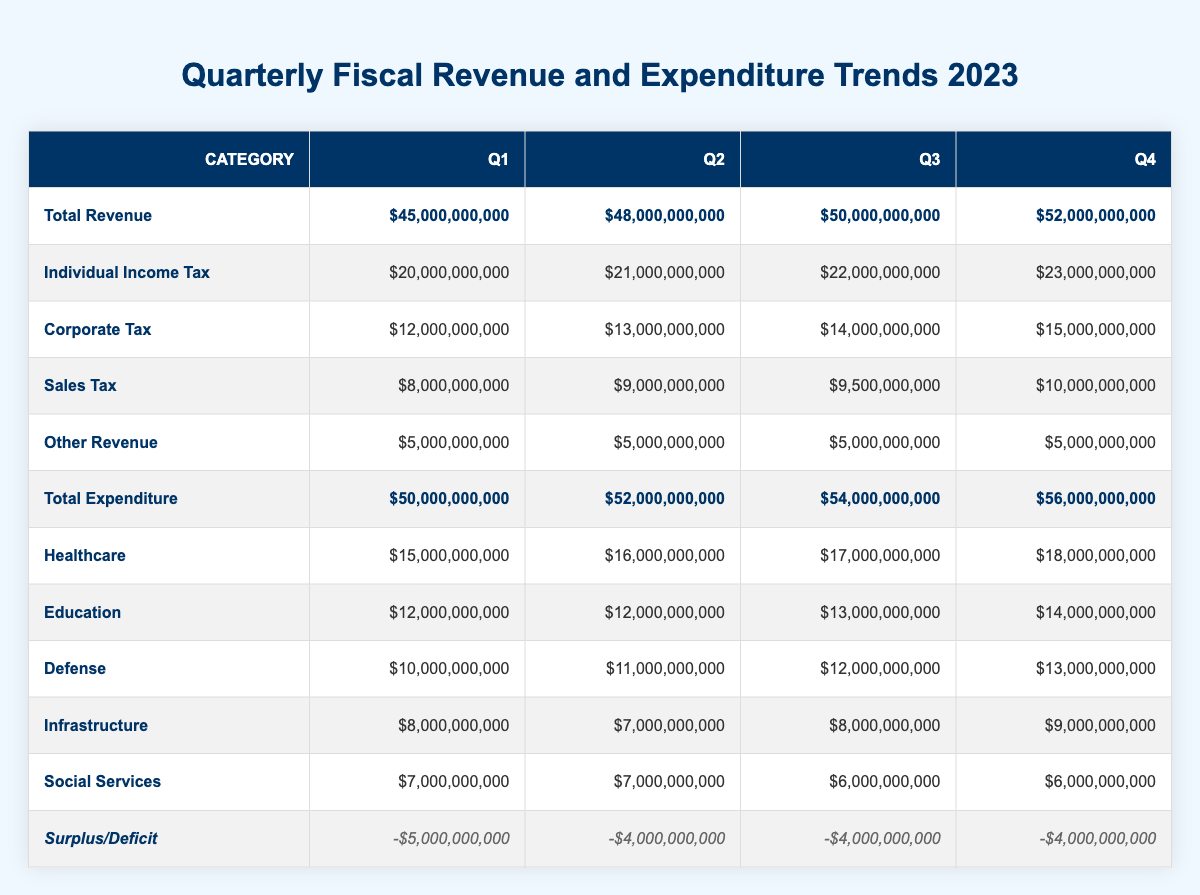What is the total revenue for Q3? The table lists the total revenue for each quarter. For Q3, it shows $50,000,000,000 as the total revenue.
Answer: $50,000,000,000 What was the total expenditure in Q2? The table provides the total expenditure for each quarter. For Q2, the total expenditure is $52,000,000,000.
Answer: $52,000,000,000 In which quarter was the highest individual income tax collected, and what was the amount? The table shows individual income tax for each quarter. The highest amount is $23,000,000,000 in Q4.
Answer: Q4, $23,000,000,000 What is the average total revenue across all quarters? The total revenues for each quarter are $45,000,000,000 (Q1), $48,000,000,000 (Q2), $50,000,000,000 (Q3), and $52,000,000,000 (Q4). The average is calculated as (45 + 48 + 50 + 52) / 4 = 48.75 billion.
Answer: $48,750,000,000 Is the total expenditure higher than total revenue in all quarters? By comparing total revenue and total expenditure for each quarter, in Q1 ($45B vs. $50B), Q2 ($48B vs. $52B), Q3 ($50B vs. $54B), and Q4 ($52B vs. $56B), the expenditure is indeed higher in all four quarters.
Answer: Yes What was the change in corporate tax from Q1 to Q4? The corporate tax for Q1 is $12,000,000,000 and for Q4 is $15,000,000,000. The change is $15B - $12B = $3B increase.
Answer: $3,000,000,000 increase Which expenditure category had the largest increase from Q1 to Q4? The healthcare category in Q1 was $15,000,000,000 and in Q4 was $18,000,000,000, showing an increase of $3,000,000,000. The defense category also increased from $10B to $13B, also $3B. However, healthcare and defense had the same increase.
Answer: Healthcare and Defense, $3,000,000,000 increase each If we consider social services as an expenditure category, how did the total social services expenditure change from Q1 to Q4? In Q1, social services expenditure was $7,000,000,000 and in Q4 it is $6,000,000,000. Therefore, it decreased by $1,000,000,000.
Answer: Decreased by $1,000,000,000 What was the total surplus/deficit for Q3? The table lists the surplus/deficit for each quarter. For Q3, it shows -$4,000,000,000, indicating a deficit.
Answer: -$4,000,000,000 (deficit) Is the revenue from sales tax increasing every quarter? The sales tax amounts listed are $8,000,000,000 (Q1), $9,000,000,000 (Q2), $9,500,000,000 (Q3), and $10,000,000,000 (Q4). Since all values are rising from Q1 to Q4, the answer is yes.
Answer: Yes 